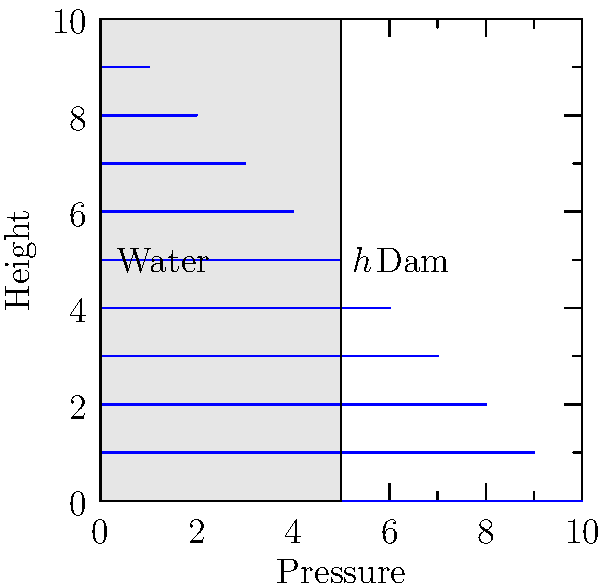As a developer working on improving project documentation, you need to create a guideline for calculating water pressure distribution on a dam wall. Given a rectangular dam of height $h = 10$ m and base width $w = 5$ m, with water on one side up to the top, calculate the total horizontal force $F$ (in kN) exerted by the water on the dam wall. Assume the specific weight of water $\gamma = 9.81$ kN/m³. To calculate the total horizontal force exerted by the water on the dam wall, we need to follow these steps:

1) The pressure distribution on the dam wall is triangular, with zero pressure at the top and maximum pressure at the bottom.

2) The maximum pressure at the bottom of the dam is:
   $$p_{max} = \gamma h = 9.81 \times 10 = 98.1 \text{ kN/m²}$$

3) The average pressure over the height of the dam is:
   $$p_{avg} = \frac{p_{max}}{2} = \frac{98.1}{2} = 49.05 \text{ kN/m²}$$

4) The total force is the product of the average pressure and the area of the dam wall:
   $$F = p_{avg} \times \text{Area} = 49.05 \times (10 \times 1) = 490.5 \text{ kN}$$

   Note: We use a unit width of 1 m for the calculation.

5) Therefore, the total horizontal force exerted by the water on the dam wall is 490.5 kN.
Answer: 490.5 kN 